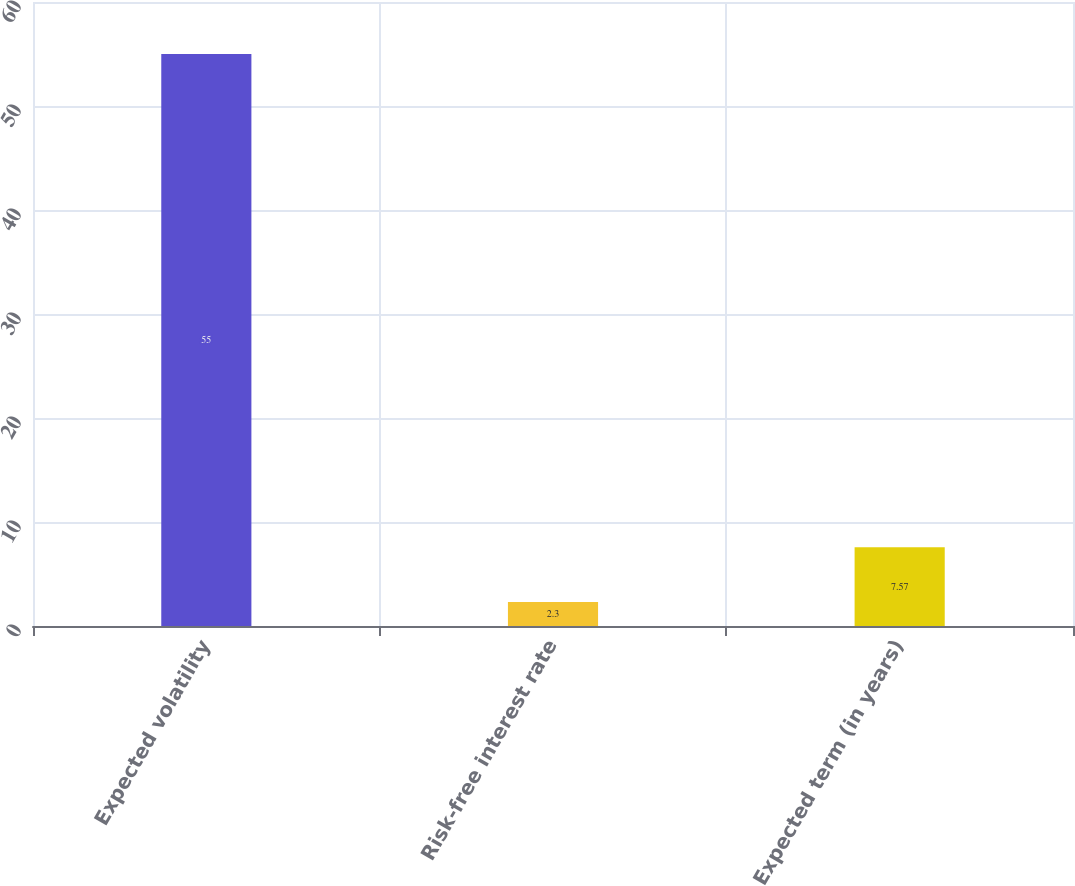Convert chart. <chart><loc_0><loc_0><loc_500><loc_500><bar_chart><fcel>Expected volatility<fcel>Risk-free interest rate<fcel>Expected term (in years)<nl><fcel>55<fcel>2.3<fcel>7.57<nl></chart> 